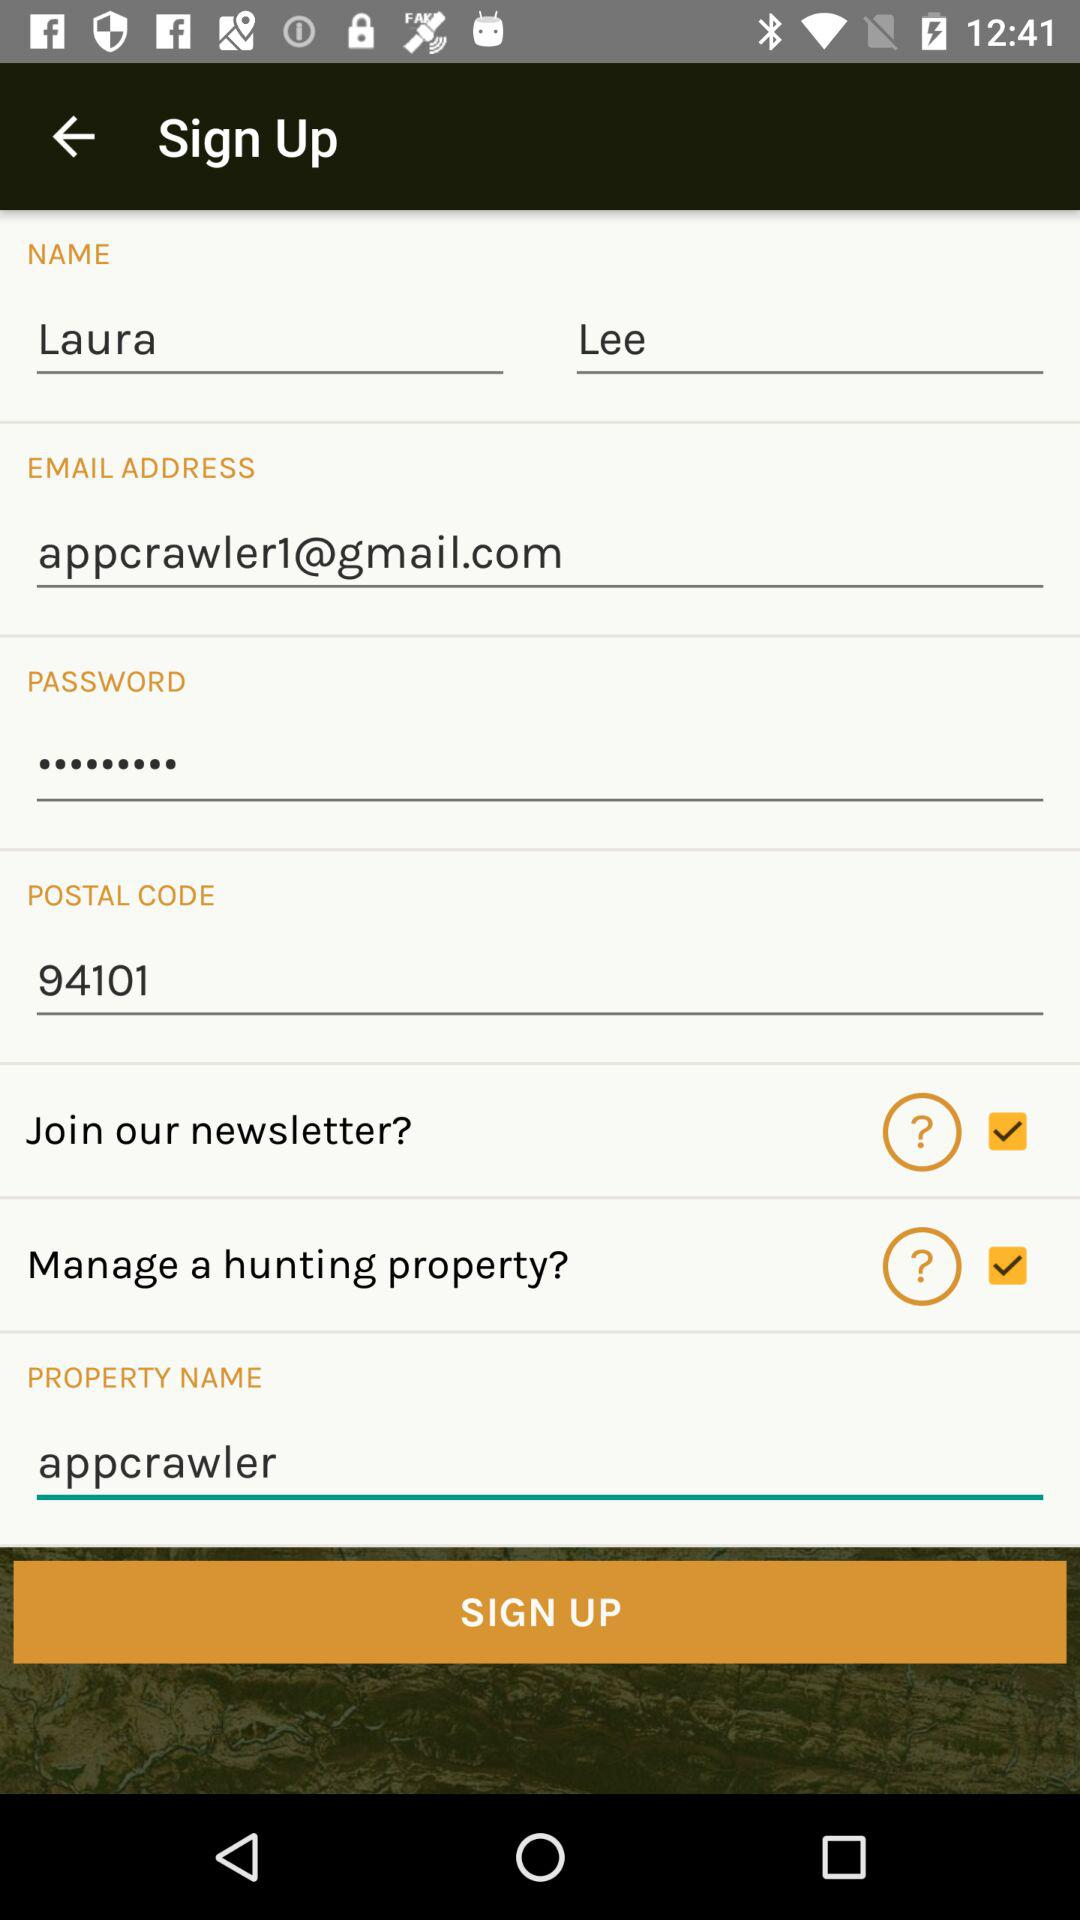What is the postal code? The postal code is 94101. 